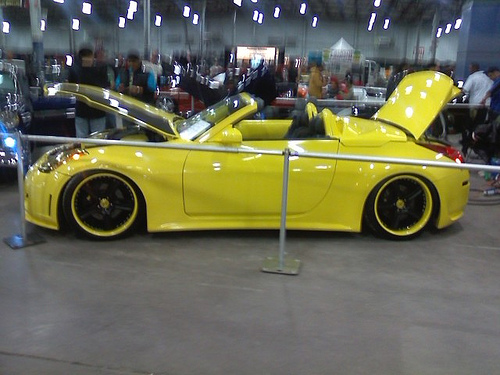<image>
Can you confirm if the rim is under the pole? Yes. The rim is positioned underneath the pole, with the pole above it in the vertical space. Where is the car in relation to the ground? Is it next to the ground? Yes. The car is positioned adjacent to the ground, located nearby in the same general area. 